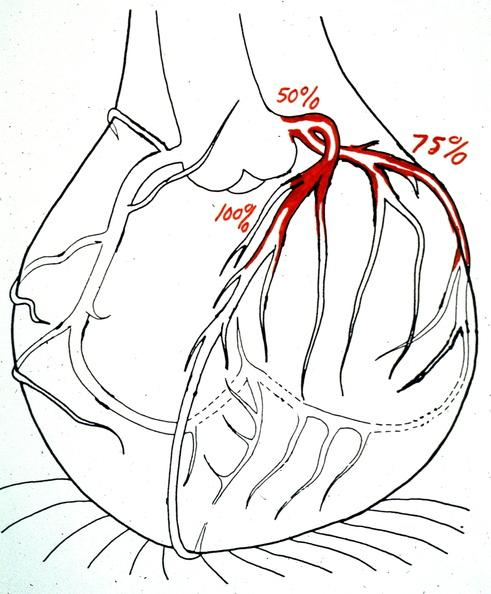what is present?
Answer the question using a single word or phrase. Cardiovascular 